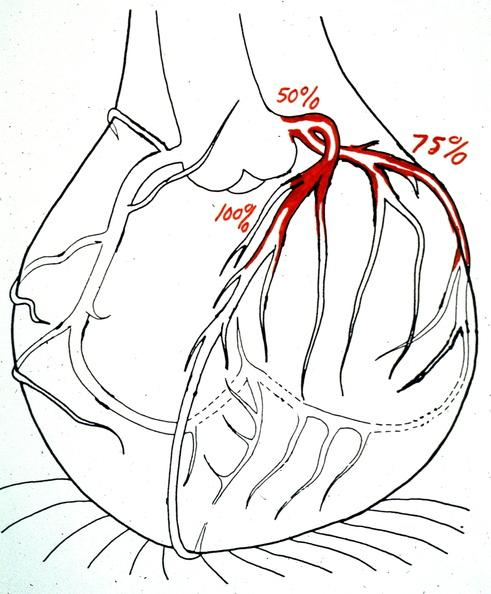what is present?
Answer the question using a single word or phrase. Cardiovascular 